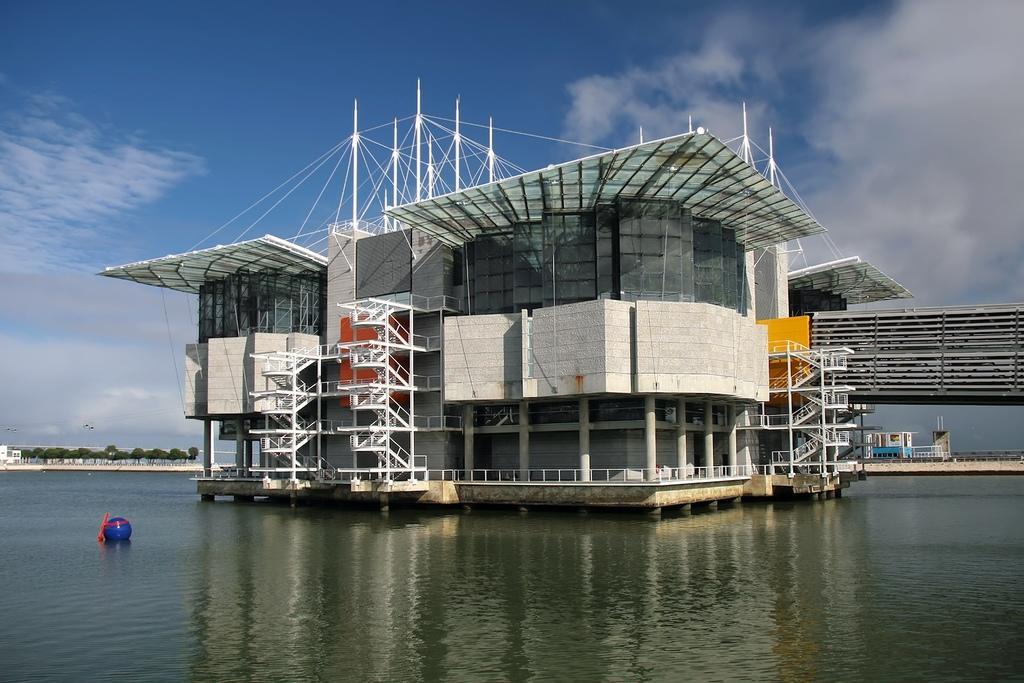Describe this image in one or two sentences. There is water. In the water there is a building with pillars, staircases, poles. In the background there is sky and trees. In the water there is a blue color thing. 